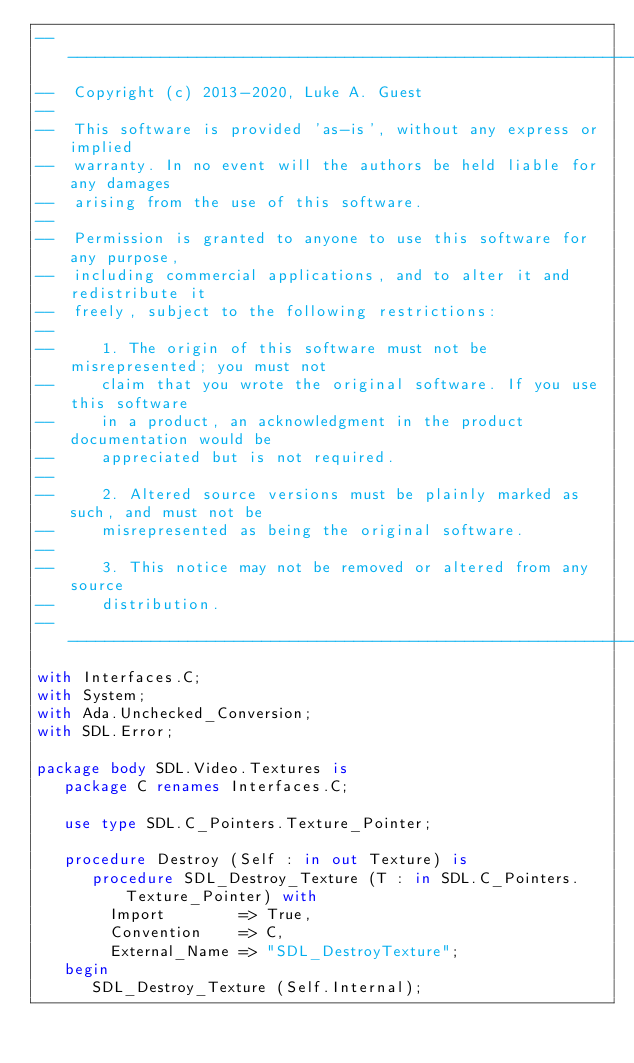<code> <loc_0><loc_0><loc_500><loc_500><_Ada_>--------------------------------------------------------------------------------------------------------------------
--  Copyright (c) 2013-2020, Luke A. Guest
--
--  This software is provided 'as-is', without any express or implied
--  warranty. In no event will the authors be held liable for any damages
--  arising from the use of this software.
--
--  Permission is granted to anyone to use this software for any purpose,
--  including commercial applications, and to alter it and redistribute it
--  freely, subject to the following restrictions:
--
--     1. The origin of this software must not be misrepresented; you must not
--     claim that you wrote the original software. If you use this software
--     in a product, an acknowledgment in the product documentation would be
--     appreciated but is not required.
--
--     2. Altered source versions must be plainly marked as such, and must not be
--     misrepresented as being the original software.
--
--     3. This notice may not be removed or altered from any source
--     distribution.
--------------------------------------------------------------------------------------------------------------------
with Interfaces.C;
with System;
with Ada.Unchecked_Conversion;
with SDL.Error;

package body SDL.Video.Textures is
   package C renames Interfaces.C;

   use type SDL.C_Pointers.Texture_Pointer;

   procedure Destroy (Self : in out Texture) is
      procedure SDL_Destroy_Texture (T : in SDL.C_Pointers.Texture_Pointer) with
        Import        => True,
        Convention    => C,
        External_Name => "SDL_DestroyTexture";
   begin
      SDL_Destroy_Texture (Self.Internal);
</code> 